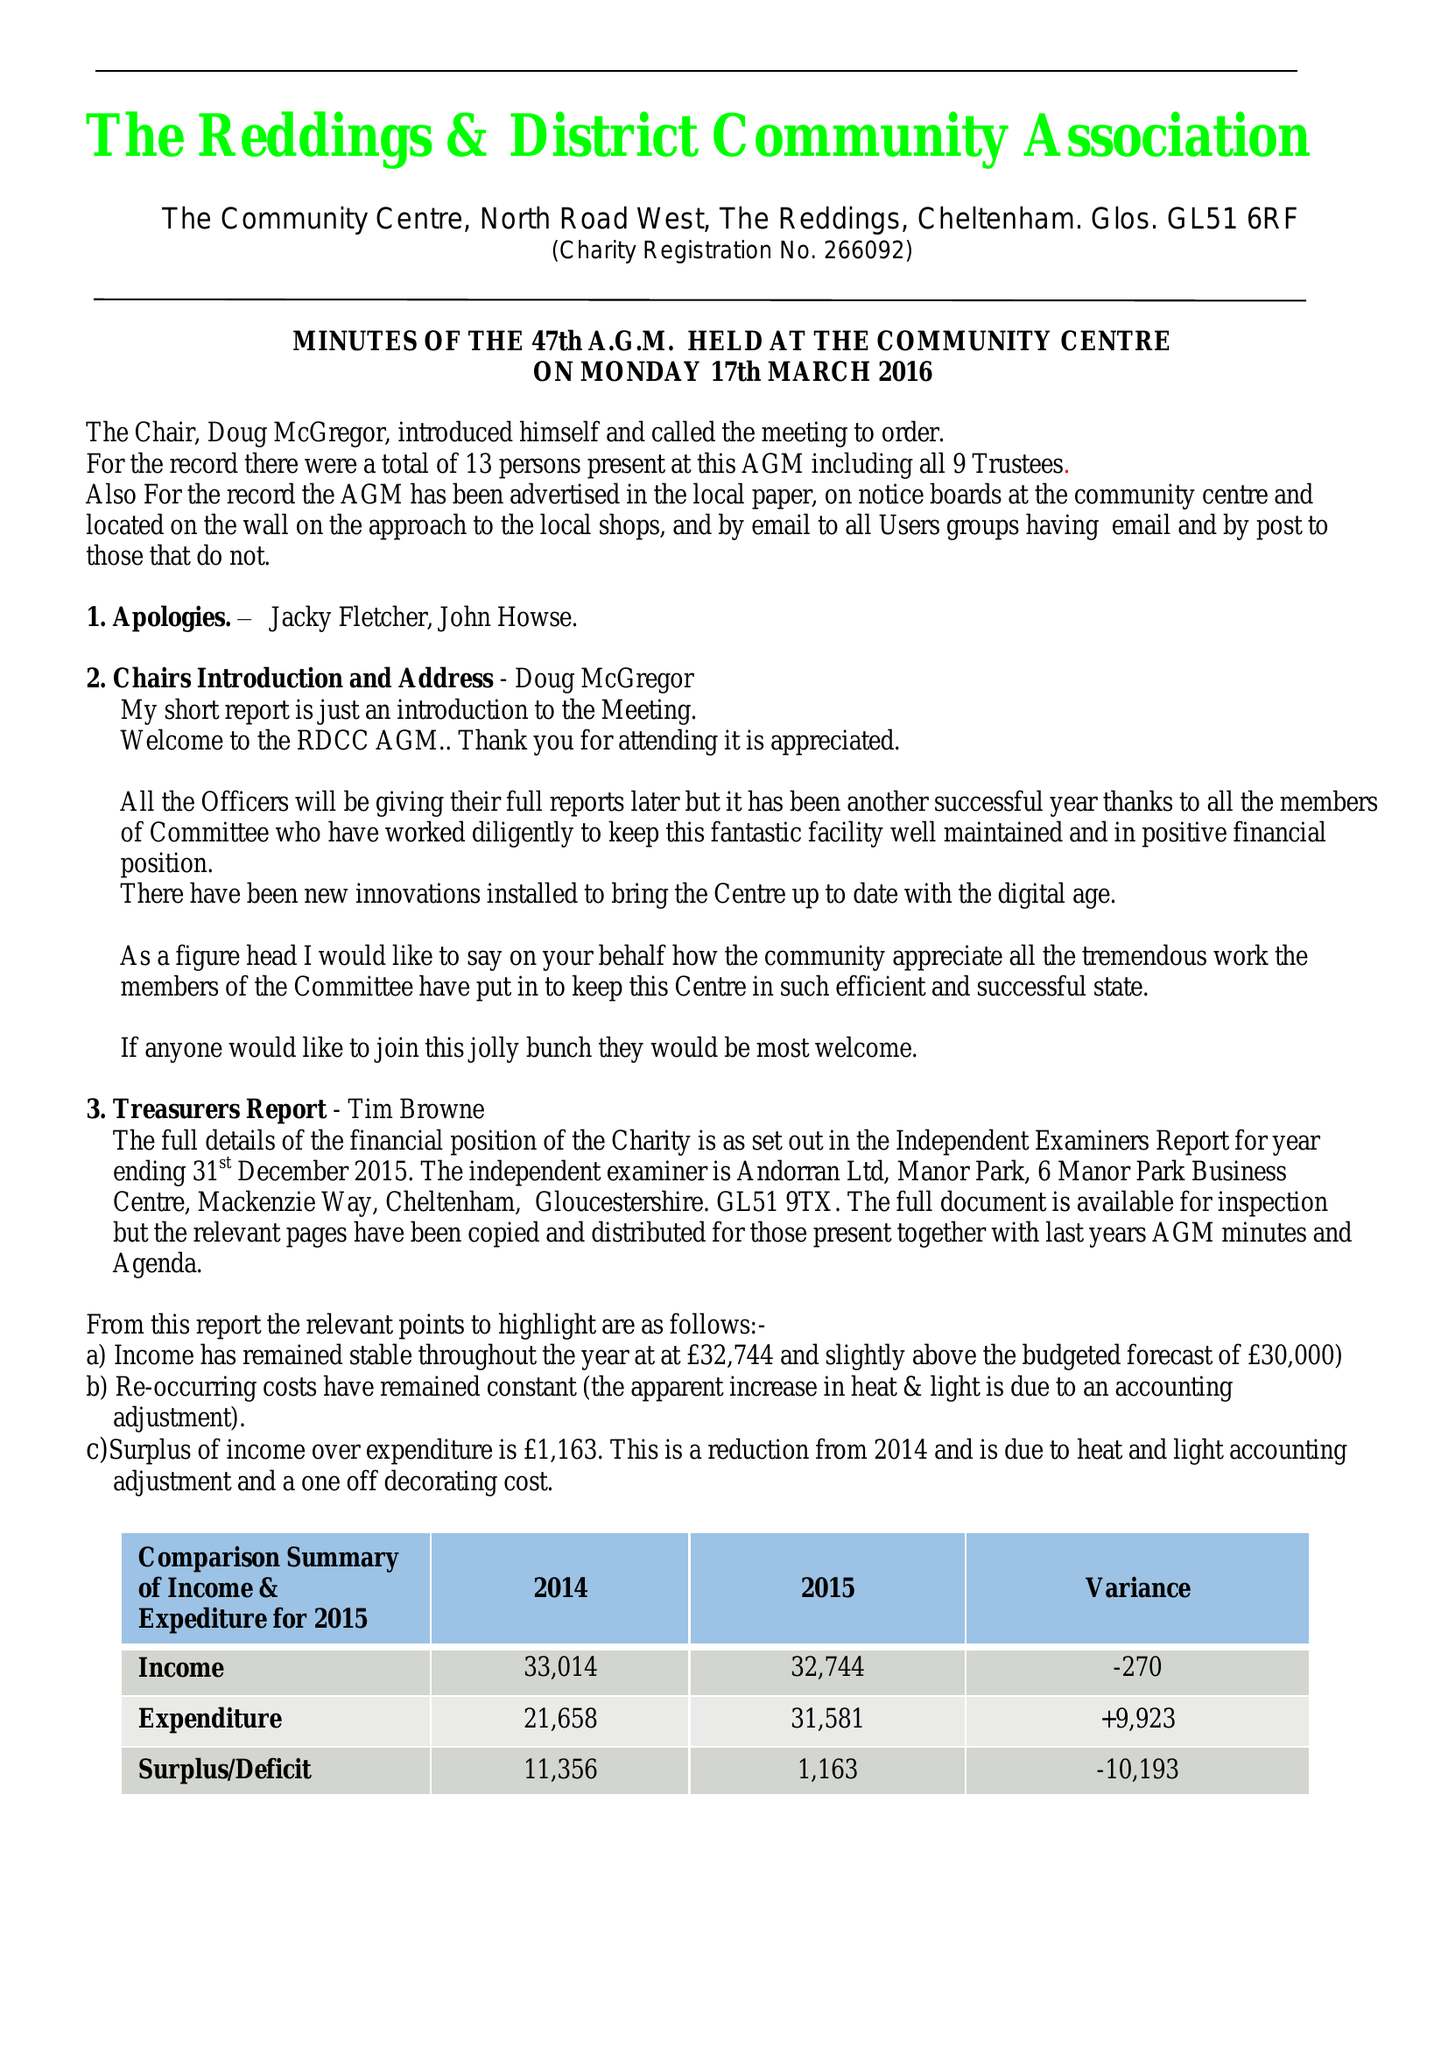What is the value for the report_date?
Answer the question using a single word or phrase. 2015-12-31 